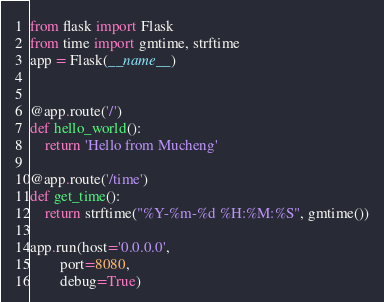Convert code to text. <code><loc_0><loc_0><loc_500><loc_500><_Python_>from flask import Flask
from time import gmtime, strftime
app = Flask(__name__)


@app.route('/')
def hello_world():
    return 'Hello from Mucheng'

@app.route('/time')
def get_time():
    return strftime("%Y-%m-%d %H:%M:%S", gmtime())

app.run(host='0.0.0.0',
        port=8080,
        debug=True)
</code> 